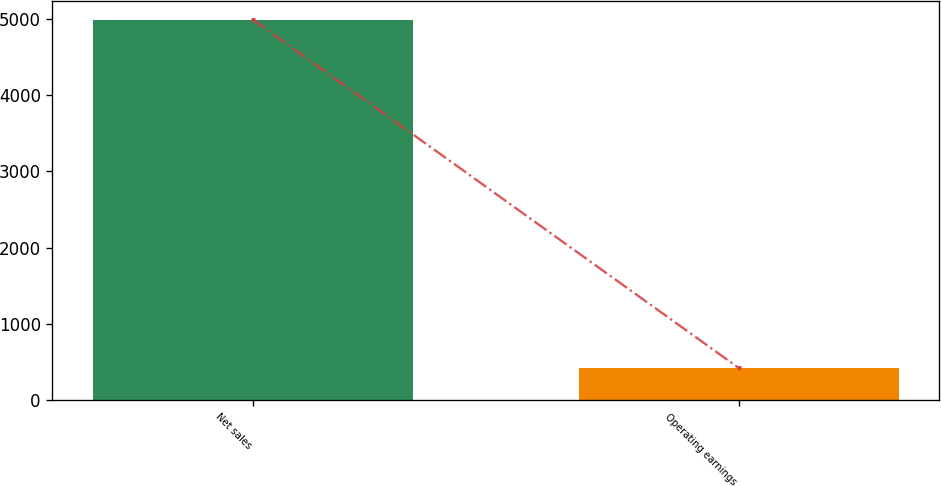<chart> <loc_0><loc_0><loc_500><loc_500><bar_chart><fcel>Net sales<fcel>Operating earnings<nl><fcel>4993<fcel>421<nl></chart> 